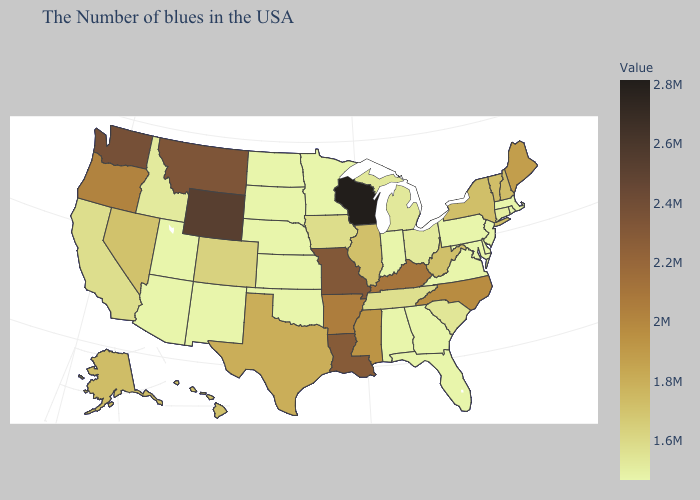Does Louisiana have the highest value in the South?
Write a very short answer. Yes. Which states have the lowest value in the USA?
Concise answer only. Massachusetts, Rhode Island, New Jersey, Delaware, Maryland, Pennsylvania, Virginia, Florida, Georgia, Indiana, Alabama, Minnesota, Kansas, Nebraska, Oklahoma, South Dakota, North Dakota, New Mexico, Utah, Arizona. Does Missouri have a lower value than New Hampshire?
Keep it brief. No. Which states have the lowest value in the Northeast?
Concise answer only. Massachusetts, Rhode Island, New Jersey, Pennsylvania. Among the states that border Oregon , which have the lowest value?
Give a very brief answer. Idaho. Among the states that border Georgia , which have the lowest value?
Quick response, please. Florida, Alabama. Which states hav the highest value in the South?
Give a very brief answer. Louisiana. Which states have the lowest value in the MidWest?
Quick response, please. Indiana, Minnesota, Kansas, Nebraska, South Dakota, North Dakota. 